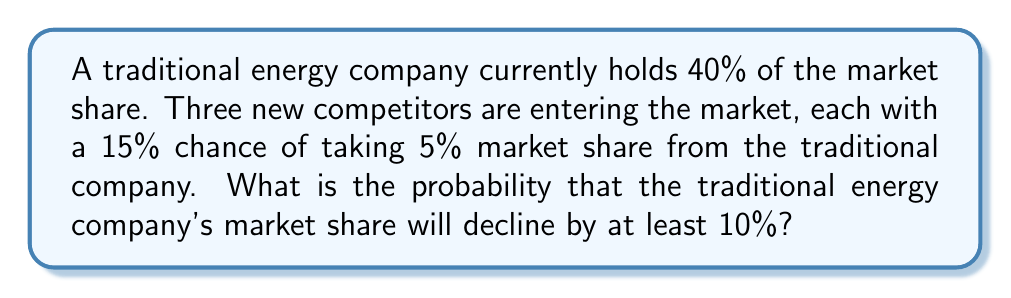Help me with this question. Let's approach this step-by-step:

1) For the company to lose at least 10% market share, at least two competitors must succeed in taking 5% each.

2) We can model this as a binomial probability problem. Let $X$ be the number of successful competitors.

3) The probability of success for each competitor is 0.15, and there are 3 competitors.

4) We need to find $P(X \geq 2)$, which is equal to $P(X = 2) + P(X = 3)$.

5) The probability mass function for a binomial distribution is:

   $$P(X = k) = \binom{n}{k} p^k (1-p)^{n-k}$$

   where $n$ is the number of trials, $k$ is the number of successes, and $p$ is the probability of success.

6) In our case, $n = 3$, $p = 0.15$, and we need to calculate for $k = 2$ and $k = 3$:

   $$P(X = 2) = \binom{3}{2} (0.15)^2 (0.85)^1 = 3 \cdot 0.0225 \cdot 0.85 = 0.057375$$

   $$P(X = 3) = \binom{3}{3} (0.15)^3 (0.85)^0 = 1 \cdot 0.003375 \cdot 1 = 0.003375$$

7) Therefore, $P(X \geq 2) = P(X = 2) + P(X = 3) = 0.057375 + 0.003375 = 0.06075$
Answer: 0.06075 